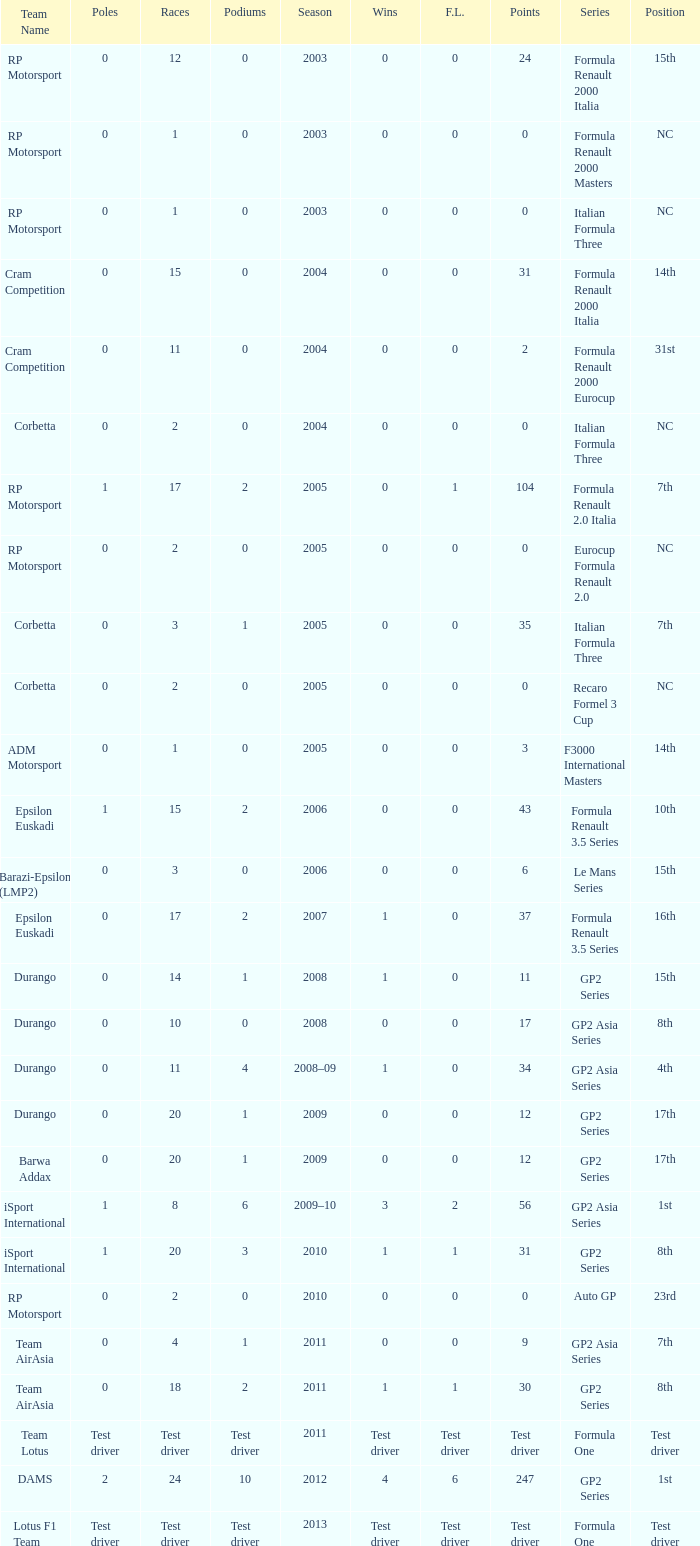What is the number of podiums with 0 wins, 0 F.L. and 35 points? 1.0. Can you give me this table as a dict? {'header': ['Team Name', 'Poles', 'Races', 'Podiums', 'Season', 'Wins', 'F.L.', 'Points', 'Series', 'Position'], 'rows': [['RP Motorsport', '0', '12', '0', '2003', '0', '0', '24', 'Formula Renault 2000 Italia', '15th'], ['RP Motorsport', '0', '1', '0', '2003', '0', '0', '0', 'Formula Renault 2000 Masters', 'NC'], ['RP Motorsport', '0', '1', '0', '2003', '0', '0', '0', 'Italian Formula Three', 'NC'], ['Cram Competition', '0', '15', '0', '2004', '0', '0', '31', 'Formula Renault 2000 Italia', '14th'], ['Cram Competition', '0', '11', '0', '2004', '0', '0', '2', 'Formula Renault 2000 Eurocup', '31st'], ['Corbetta', '0', '2', '0', '2004', '0', '0', '0', 'Italian Formula Three', 'NC'], ['RP Motorsport', '1', '17', '2', '2005', '0', '1', '104', 'Formula Renault 2.0 Italia', '7th'], ['RP Motorsport', '0', '2', '0', '2005', '0', '0', '0', 'Eurocup Formula Renault 2.0', 'NC'], ['Corbetta', '0', '3', '1', '2005', '0', '0', '35', 'Italian Formula Three', '7th'], ['Corbetta', '0', '2', '0', '2005', '0', '0', '0', 'Recaro Formel 3 Cup', 'NC'], ['ADM Motorsport', '0', '1', '0', '2005', '0', '0', '3', 'F3000 International Masters', '14th'], ['Epsilon Euskadi', '1', '15', '2', '2006', '0', '0', '43', 'Formula Renault 3.5 Series', '10th'], ['Barazi-Epsilon (LMP2)', '0', '3', '0', '2006', '0', '0', '6', 'Le Mans Series', '15th'], ['Epsilon Euskadi', '0', '17', '2', '2007', '1', '0', '37', 'Formula Renault 3.5 Series', '16th'], ['Durango', '0', '14', '1', '2008', '1', '0', '11', 'GP2 Series', '15th'], ['Durango', '0', '10', '0', '2008', '0', '0', '17', 'GP2 Asia Series', '8th'], ['Durango', '0', '11', '4', '2008–09', '1', '0', '34', 'GP2 Asia Series', '4th'], ['Durango', '0', '20', '1', '2009', '0', '0', '12', 'GP2 Series', '17th'], ['Barwa Addax', '0', '20', '1', '2009', '0', '0', '12', 'GP2 Series', '17th'], ['iSport International', '1', '8', '6', '2009–10', '3', '2', '56', 'GP2 Asia Series', '1st'], ['iSport International', '1', '20', '3', '2010', '1', '1', '31', 'GP2 Series', '8th'], ['RP Motorsport', '0', '2', '0', '2010', '0', '0', '0', 'Auto GP', '23rd'], ['Team AirAsia', '0', '4', '1', '2011', '0', '0', '9', 'GP2 Asia Series', '7th'], ['Team AirAsia', '0', '18', '2', '2011', '1', '1', '30', 'GP2 Series', '8th'], ['Team Lotus', 'Test driver', 'Test driver', 'Test driver', '2011', 'Test driver', 'Test driver', 'Test driver', 'Formula One', 'Test driver'], ['DAMS', '2', '24', '10', '2012', '4', '6', '247', 'GP2 Series', '1st'], ['Lotus F1 Team', 'Test driver', 'Test driver', 'Test driver', '2013', 'Test driver', 'Test driver', 'Test driver', 'Formula One', 'Test driver']]} 